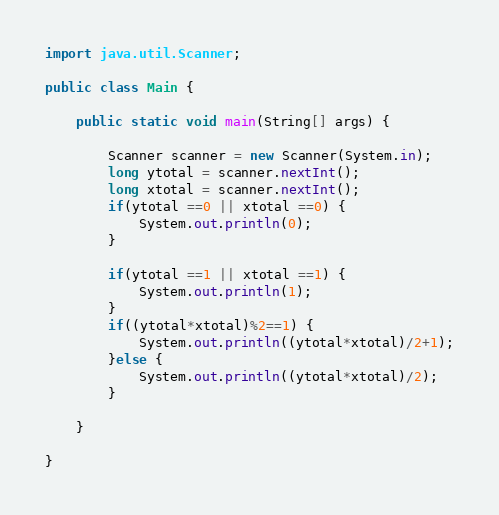<code> <loc_0><loc_0><loc_500><loc_500><_Java_>import java.util.Scanner;

public class Main {
	
	public static void main(String[] args) {
		
		Scanner scanner = new Scanner(System.in);
		long ytotal = scanner.nextInt();
		long xtotal = scanner.nextInt();
		if(ytotal ==0 || xtotal ==0) {
			System.out.println(0);
		}
		
		if(ytotal ==1 || xtotal ==1) {
			System.out.println(1);
		}
		if((ytotal*xtotal)%2==1) {
			System.out.println((ytotal*xtotal)/2+1);
		}else {
			System.out.println((ytotal*xtotal)/2);
		}

	}
			
}</code> 